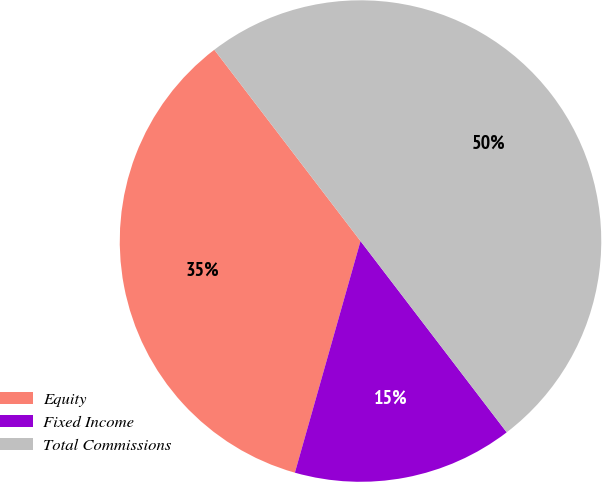Convert chart to OTSL. <chart><loc_0><loc_0><loc_500><loc_500><pie_chart><fcel>Equity<fcel>Fixed Income<fcel>Total Commissions<nl><fcel>35.22%<fcel>14.78%<fcel>50.0%<nl></chart> 